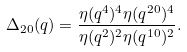Convert formula to latex. <formula><loc_0><loc_0><loc_500><loc_500>\Delta _ { 2 0 } ( q ) = \frac { \eta ( q ^ { 4 } ) ^ { 4 } \eta ( q ^ { 2 0 } ) ^ { 4 } } { \eta ( q ^ { 2 } ) ^ { 2 } \eta ( q ^ { 1 0 } ) ^ { 2 } } .</formula> 